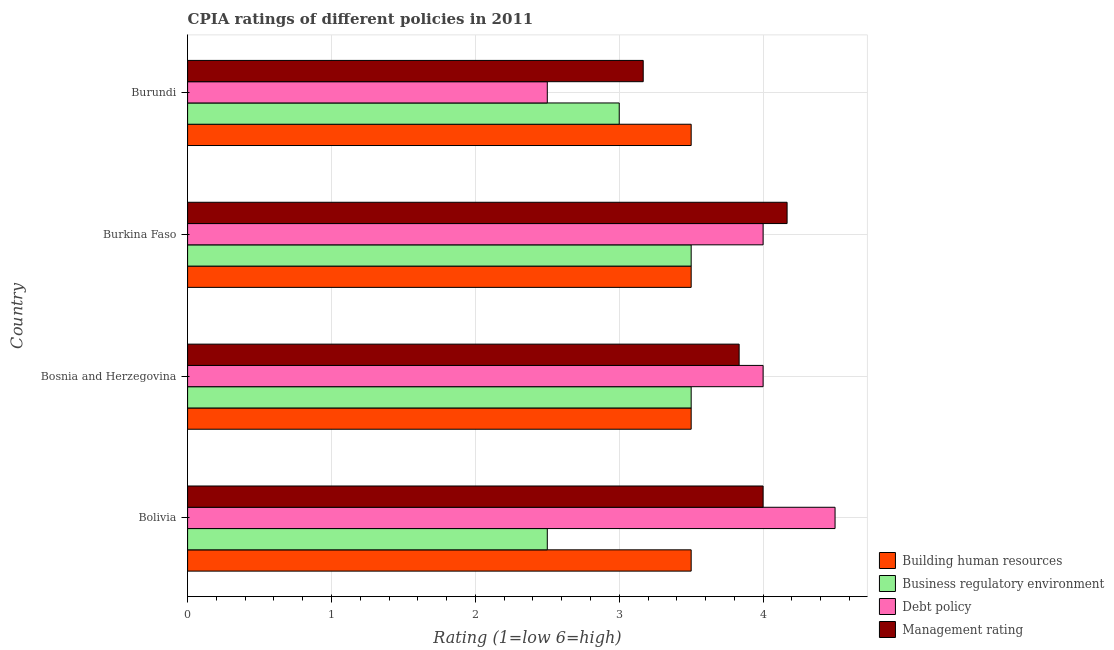How many different coloured bars are there?
Offer a terse response. 4. How many groups of bars are there?
Offer a very short reply. 4. Are the number of bars per tick equal to the number of legend labels?
Ensure brevity in your answer.  Yes. Are the number of bars on each tick of the Y-axis equal?
Give a very brief answer. Yes. How many bars are there on the 1st tick from the top?
Keep it short and to the point. 4. How many bars are there on the 2nd tick from the bottom?
Your answer should be compact. 4. In how many cases, is the number of bars for a given country not equal to the number of legend labels?
Your answer should be compact. 0. What is the cpia rating of management in Bosnia and Herzegovina?
Provide a short and direct response. 3.83. Across all countries, what is the minimum cpia rating of debt policy?
Your response must be concise. 2.5. In which country was the cpia rating of business regulatory environment minimum?
Give a very brief answer. Bolivia. What is the average cpia rating of building human resources per country?
Offer a very short reply. 3.5. In how many countries, is the cpia rating of building human resources greater than 3.4 ?
Offer a terse response. 4. What is the ratio of the cpia rating of business regulatory environment in Bolivia to that in Burundi?
Your response must be concise. 0.83. What is the difference between the highest and the second highest cpia rating of debt policy?
Offer a very short reply. 0.5. Is the sum of the cpia rating of business regulatory environment in Bosnia and Herzegovina and Burkina Faso greater than the maximum cpia rating of management across all countries?
Give a very brief answer. Yes. What does the 2nd bar from the top in Burundi represents?
Your answer should be very brief. Debt policy. What does the 4th bar from the bottom in Bosnia and Herzegovina represents?
Give a very brief answer. Management rating. Is it the case that in every country, the sum of the cpia rating of building human resources and cpia rating of business regulatory environment is greater than the cpia rating of debt policy?
Give a very brief answer. Yes. How many bars are there?
Your answer should be very brief. 16. Are all the bars in the graph horizontal?
Offer a very short reply. Yes. How many countries are there in the graph?
Make the answer very short. 4. Does the graph contain grids?
Offer a terse response. Yes. How many legend labels are there?
Provide a short and direct response. 4. How are the legend labels stacked?
Make the answer very short. Vertical. What is the title of the graph?
Provide a succinct answer. CPIA ratings of different policies in 2011. What is the label or title of the Y-axis?
Ensure brevity in your answer.  Country. What is the Rating (1=low 6=high) in Building human resources in Bolivia?
Ensure brevity in your answer.  3.5. What is the Rating (1=low 6=high) of Management rating in Bosnia and Herzegovina?
Provide a succinct answer. 3.83. What is the Rating (1=low 6=high) in Business regulatory environment in Burkina Faso?
Give a very brief answer. 3.5. What is the Rating (1=low 6=high) of Management rating in Burkina Faso?
Make the answer very short. 4.17. What is the Rating (1=low 6=high) of Management rating in Burundi?
Your answer should be compact. 3.17. Across all countries, what is the maximum Rating (1=low 6=high) in Business regulatory environment?
Provide a short and direct response. 3.5. Across all countries, what is the maximum Rating (1=low 6=high) in Management rating?
Your answer should be very brief. 4.17. Across all countries, what is the minimum Rating (1=low 6=high) of Debt policy?
Make the answer very short. 2.5. Across all countries, what is the minimum Rating (1=low 6=high) of Management rating?
Your answer should be very brief. 3.17. What is the total Rating (1=low 6=high) of Building human resources in the graph?
Keep it short and to the point. 14. What is the total Rating (1=low 6=high) in Business regulatory environment in the graph?
Ensure brevity in your answer.  12.5. What is the total Rating (1=low 6=high) of Debt policy in the graph?
Ensure brevity in your answer.  15. What is the total Rating (1=low 6=high) in Management rating in the graph?
Make the answer very short. 15.17. What is the difference between the Rating (1=low 6=high) in Building human resources in Bolivia and that in Bosnia and Herzegovina?
Offer a terse response. 0. What is the difference between the Rating (1=low 6=high) of Building human resources in Bolivia and that in Burkina Faso?
Your answer should be compact. 0. What is the difference between the Rating (1=low 6=high) in Business regulatory environment in Bolivia and that in Burkina Faso?
Keep it short and to the point. -1. What is the difference between the Rating (1=low 6=high) of Debt policy in Bolivia and that in Burkina Faso?
Provide a succinct answer. 0.5. What is the difference between the Rating (1=low 6=high) of Building human resources in Bolivia and that in Burundi?
Provide a succinct answer. 0. What is the difference between the Rating (1=low 6=high) of Business regulatory environment in Bolivia and that in Burundi?
Provide a succinct answer. -0.5. What is the difference between the Rating (1=low 6=high) in Building human resources in Bosnia and Herzegovina and that in Burkina Faso?
Provide a succinct answer. 0. What is the difference between the Rating (1=low 6=high) in Business regulatory environment in Bosnia and Herzegovina and that in Burkina Faso?
Your answer should be compact. 0. What is the difference between the Rating (1=low 6=high) in Debt policy in Bosnia and Herzegovina and that in Burkina Faso?
Make the answer very short. 0. What is the difference between the Rating (1=low 6=high) in Building human resources in Bosnia and Herzegovina and that in Burundi?
Your answer should be compact. 0. What is the difference between the Rating (1=low 6=high) in Business regulatory environment in Bosnia and Herzegovina and that in Burundi?
Your response must be concise. 0.5. What is the difference between the Rating (1=low 6=high) in Debt policy in Burkina Faso and that in Burundi?
Your answer should be compact. 1.5. What is the difference between the Rating (1=low 6=high) in Management rating in Burkina Faso and that in Burundi?
Your answer should be compact. 1. What is the difference between the Rating (1=low 6=high) of Building human resources in Bolivia and the Rating (1=low 6=high) of Debt policy in Bosnia and Herzegovina?
Provide a succinct answer. -0.5. What is the difference between the Rating (1=low 6=high) in Business regulatory environment in Bolivia and the Rating (1=low 6=high) in Debt policy in Bosnia and Herzegovina?
Your answer should be compact. -1.5. What is the difference between the Rating (1=low 6=high) of Business regulatory environment in Bolivia and the Rating (1=low 6=high) of Management rating in Bosnia and Herzegovina?
Your response must be concise. -1.33. What is the difference between the Rating (1=low 6=high) of Building human resources in Bolivia and the Rating (1=low 6=high) of Debt policy in Burkina Faso?
Make the answer very short. -0.5. What is the difference between the Rating (1=low 6=high) in Business regulatory environment in Bolivia and the Rating (1=low 6=high) in Management rating in Burkina Faso?
Make the answer very short. -1.67. What is the difference between the Rating (1=low 6=high) of Building human resources in Bolivia and the Rating (1=low 6=high) of Debt policy in Burundi?
Your answer should be compact. 1. What is the difference between the Rating (1=low 6=high) in Building human resources in Bolivia and the Rating (1=low 6=high) in Management rating in Burundi?
Your answer should be very brief. 0.33. What is the difference between the Rating (1=low 6=high) of Debt policy in Bolivia and the Rating (1=low 6=high) of Management rating in Burundi?
Your answer should be compact. 1.33. What is the difference between the Rating (1=low 6=high) in Building human resources in Bosnia and Herzegovina and the Rating (1=low 6=high) in Business regulatory environment in Burkina Faso?
Offer a very short reply. 0. What is the difference between the Rating (1=low 6=high) in Business regulatory environment in Bosnia and Herzegovina and the Rating (1=low 6=high) in Management rating in Burkina Faso?
Offer a terse response. -0.67. What is the difference between the Rating (1=low 6=high) in Debt policy in Bosnia and Herzegovina and the Rating (1=low 6=high) in Management rating in Burkina Faso?
Keep it short and to the point. -0.17. What is the difference between the Rating (1=low 6=high) of Building human resources in Bosnia and Herzegovina and the Rating (1=low 6=high) of Business regulatory environment in Burundi?
Provide a succinct answer. 0.5. What is the difference between the Rating (1=low 6=high) of Debt policy in Bosnia and Herzegovina and the Rating (1=low 6=high) of Management rating in Burundi?
Your answer should be compact. 0.83. What is the difference between the Rating (1=low 6=high) of Business regulatory environment in Burkina Faso and the Rating (1=low 6=high) of Debt policy in Burundi?
Give a very brief answer. 1. What is the difference between the Rating (1=low 6=high) in Business regulatory environment in Burkina Faso and the Rating (1=low 6=high) in Management rating in Burundi?
Provide a succinct answer. 0.33. What is the difference between the Rating (1=low 6=high) in Debt policy in Burkina Faso and the Rating (1=low 6=high) in Management rating in Burundi?
Offer a terse response. 0.83. What is the average Rating (1=low 6=high) in Building human resources per country?
Your answer should be compact. 3.5. What is the average Rating (1=low 6=high) of Business regulatory environment per country?
Give a very brief answer. 3.12. What is the average Rating (1=low 6=high) in Debt policy per country?
Provide a succinct answer. 3.75. What is the average Rating (1=low 6=high) in Management rating per country?
Provide a short and direct response. 3.79. What is the difference between the Rating (1=low 6=high) of Building human resources and Rating (1=low 6=high) of Management rating in Bolivia?
Offer a terse response. -0.5. What is the difference between the Rating (1=low 6=high) of Business regulatory environment and Rating (1=low 6=high) of Management rating in Bolivia?
Provide a short and direct response. -1.5. What is the difference between the Rating (1=low 6=high) of Debt policy and Rating (1=low 6=high) of Management rating in Bolivia?
Your answer should be compact. 0.5. What is the difference between the Rating (1=low 6=high) of Building human resources and Rating (1=low 6=high) of Business regulatory environment in Bosnia and Herzegovina?
Provide a short and direct response. 0. What is the difference between the Rating (1=low 6=high) in Building human resources and Rating (1=low 6=high) in Management rating in Burkina Faso?
Make the answer very short. -0.67. What is the difference between the Rating (1=low 6=high) of Debt policy and Rating (1=low 6=high) of Management rating in Burkina Faso?
Your response must be concise. -0.17. What is the difference between the Rating (1=low 6=high) in Business regulatory environment and Rating (1=low 6=high) in Management rating in Burundi?
Your answer should be compact. -0.17. What is the ratio of the Rating (1=low 6=high) in Business regulatory environment in Bolivia to that in Bosnia and Herzegovina?
Provide a short and direct response. 0.71. What is the ratio of the Rating (1=low 6=high) in Debt policy in Bolivia to that in Bosnia and Herzegovina?
Provide a short and direct response. 1.12. What is the ratio of the Rating (1=low 6=high) in Management rating in Bolivia to that in Bosnia and Herzegovina?
Provide a short and direct response. 1.04. What is the ratio of the Rating (1=low 6=high) in Debt policy in Bolivia to that in Burkina Faso?
Give a very brief answer. 1.12. What is the ratio of the Rating (1=low 6=high) in Management rating in Bolivia to that in Burkina Faso?
Your answer should be compact. 0.96. What is the ratio of the Rating (1=low 6=high) of Building human resources in Bolivia to that in Burundi?
Make the answer very short. 1. What is the ratio of the Rating (1=low 6=high) of Debt policy in Bolivia to that in Burundi?
Offer a terse response. 1.8. What is the ratio of the Rating (1=low 6=high) in Management rating in Bolivia to that in Burundi?
Offer a very short reply. 1.26. What is the ratio of the Rating (1=low 6=high) of Building human resources in Bosnia and Herzegovina to that in Burkina Faso?
Offer a terse response. 1. What is the ratio of the Rating (1=low 6=high) of Business regulatory environment in Bosnia and Herzegovina to that in Burkina Faso?
Provide a succinct answer. 1. What is the ratio of the Rating (1=low 6=high) of Management rating in Bosnia and Herzegovina to that in Burundi?
Provide a succinct answer. 1.21. What is the ratio of the Rating (1=low 6=high) of Building human resources in Burkina Faso to that in Burundi?
Your response must be concise. 1. What is the ratio of the Rating (1=low 6=high) of Debt policy in Burkina Faso to that in Burundi?
Provide a short and direct response. 1.6. What is the ratio of the Rating (1=low 6=high) in Management rating in Burkina Faso to that in Burundi?
Your answer should be very brief. 1.32. What is the difference between the highest and the second highest Rating (1=low 6=high) in Building human resources?
Offer a terse response. 0. What is the difference between the highest and the second highest Rating (1=low 6=high) in Business regulatory environment?
Your answer should be compact. 0. What is the difference between the highest and the lowest Rating (1=low 6=high) in Business regulatory environment?
Your answer should be compact. 1. 